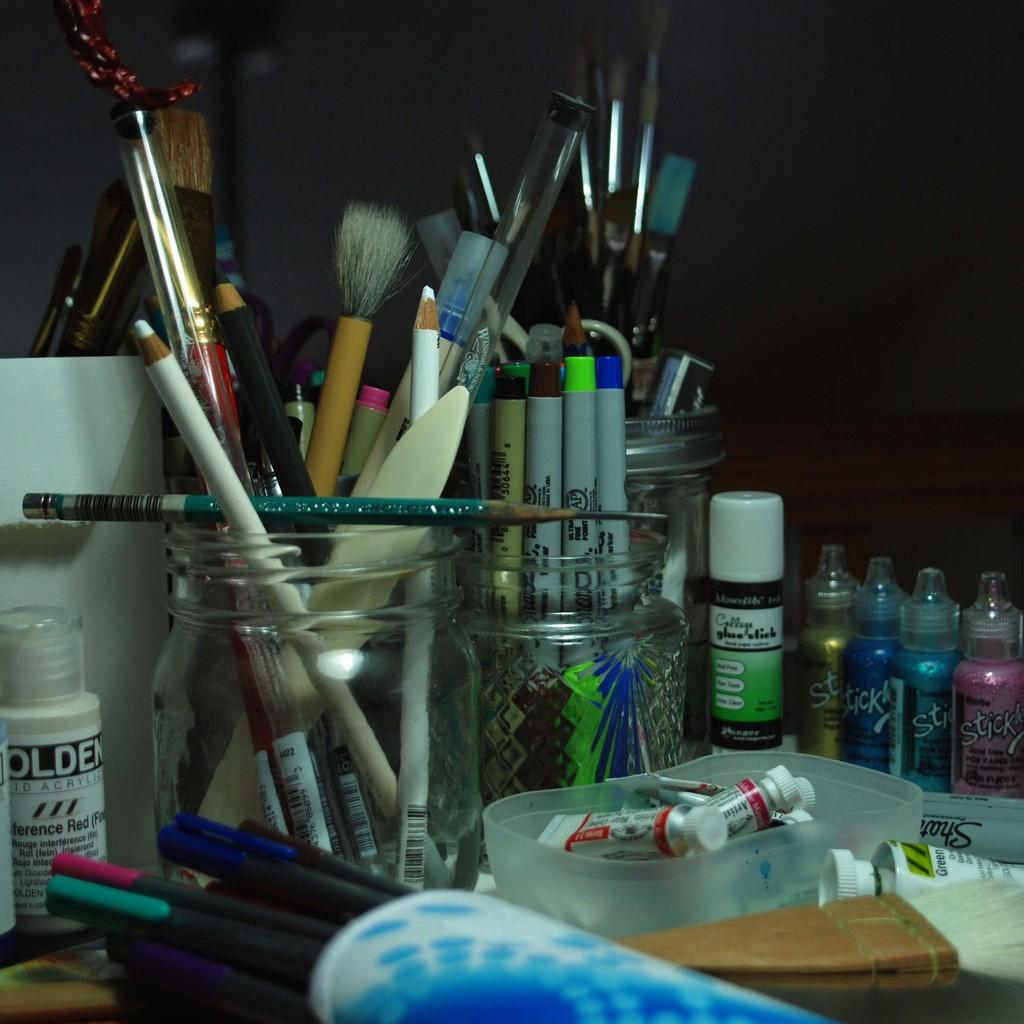<image>
Describe the image concisely. a bottle with the letters olden on it 